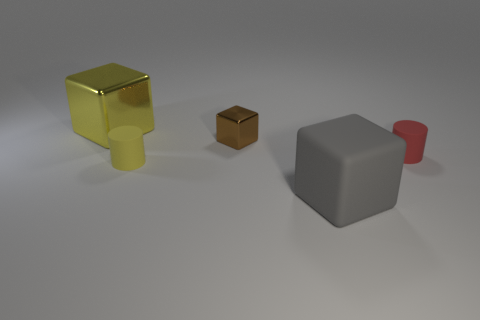Add 5 small metal things. How many objects exist? 10 Subtract all cubes. How many objects are left? 2 Add 2 large gray objects. How many large gray objects are left? 3 Add 4 matte cylinders. How many matte cylinders exist? 6 Subtract 0 red cubes. How many objects are left? 5 Subtract all cubes. Subtract all big cyan metallic cylinders. How many objects are left? 2 